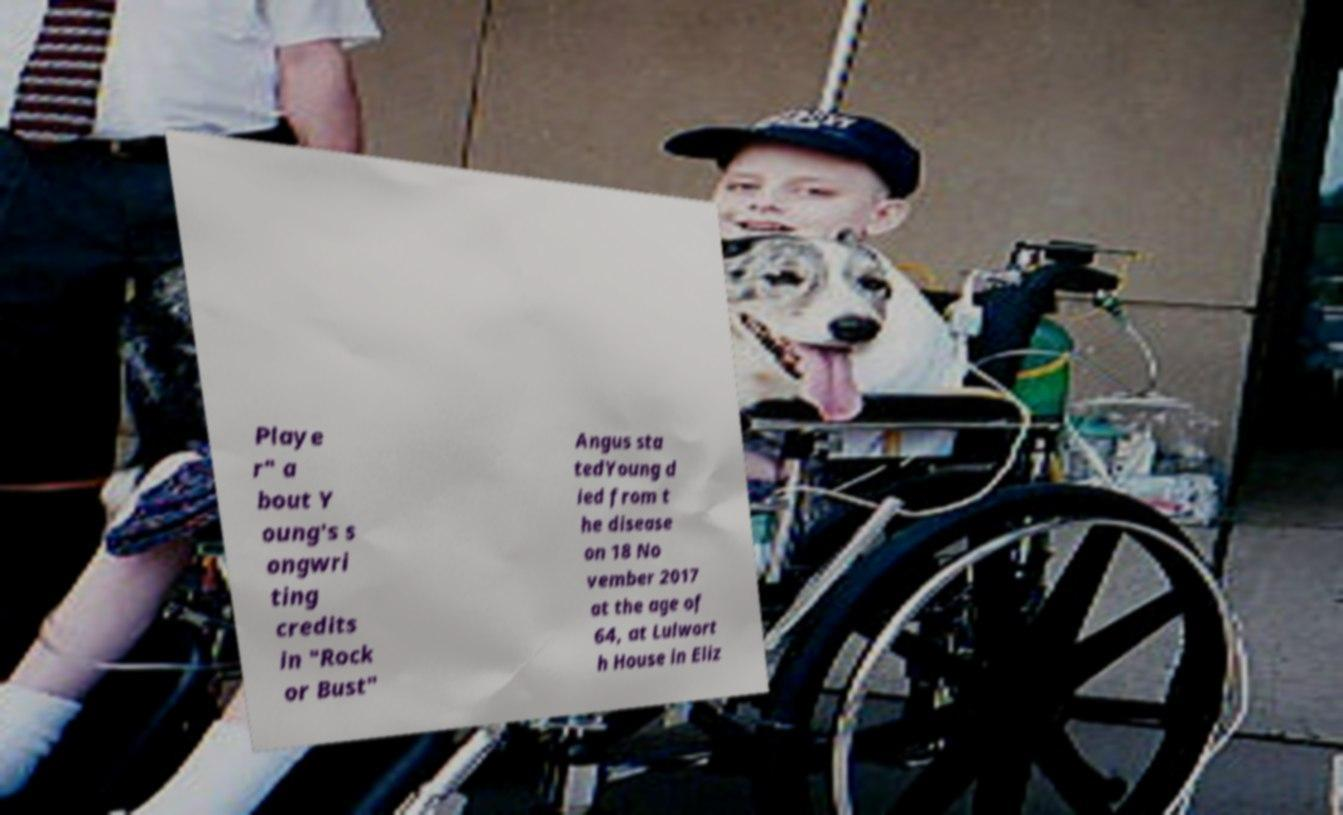There's text embedded in this image that I need extracted. Can you transcribe it verbatim? Playe r" a bout Y oung's s ongwri ting credits in "Rock or Bust" Angus sta tedYoung d ied from t he disease on 18 No vember 2017 at the age of 64, at Lulwort h House in Eliz 